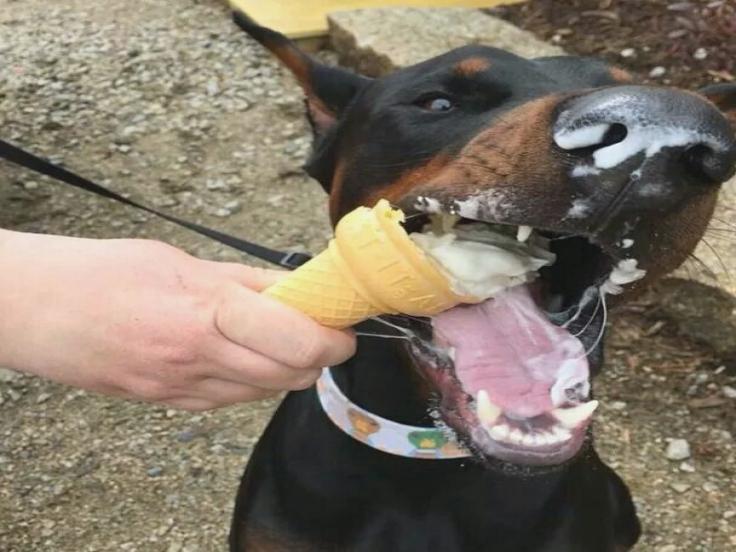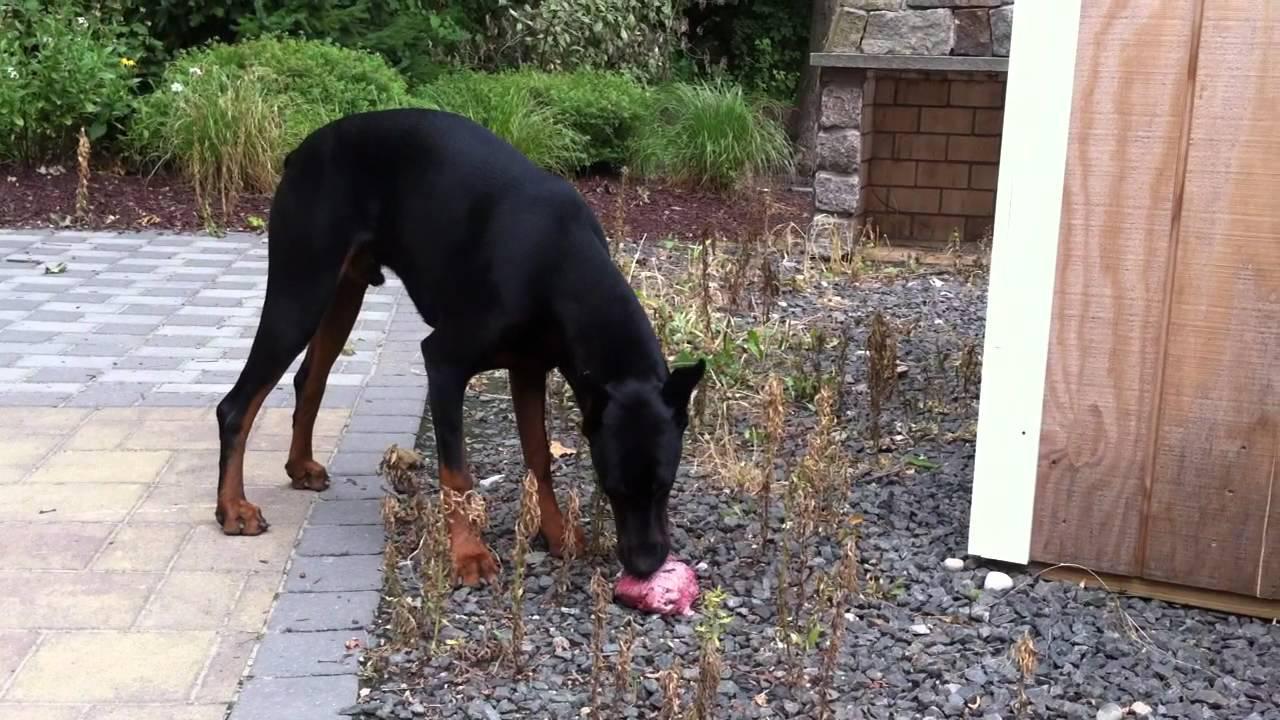The first image is the image on the left, the second image is the image on the right. For the images displayed, is the sentence "The right image contains at least three dogs." factually correct? Answer yes or no. No. The first image is the image on the left, the second image is the image on the right. Assess this claim about the two images: "One dog is laying in the grass.". Correct or not? Answer yes or no. No. 